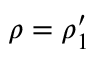Convert formula to latex. <formula><loc_0><loc_0><loc_500><loc_500>\rho = \rho _ { 1 } ^ { \prime }</formula> 